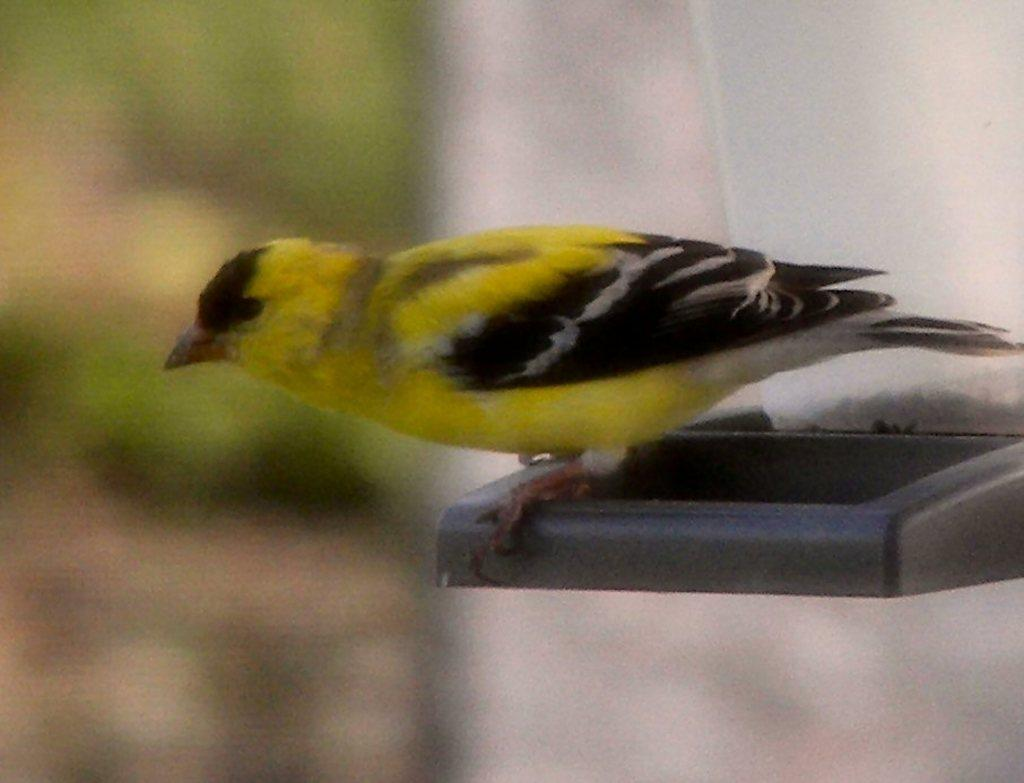What is the main subject in the foreground of the image? There is a bird in the foreground of the image. What is the bird perched on in the image? The bird is on an object in the image. Can you describe the background of the image? The background of the image is blurred. What type of thread is being used by the bird to play in the image? There is no thread or playing activity involving the bird in the image. 